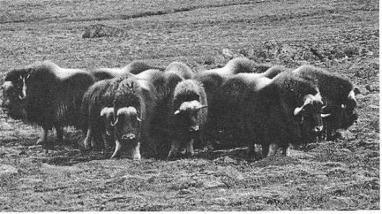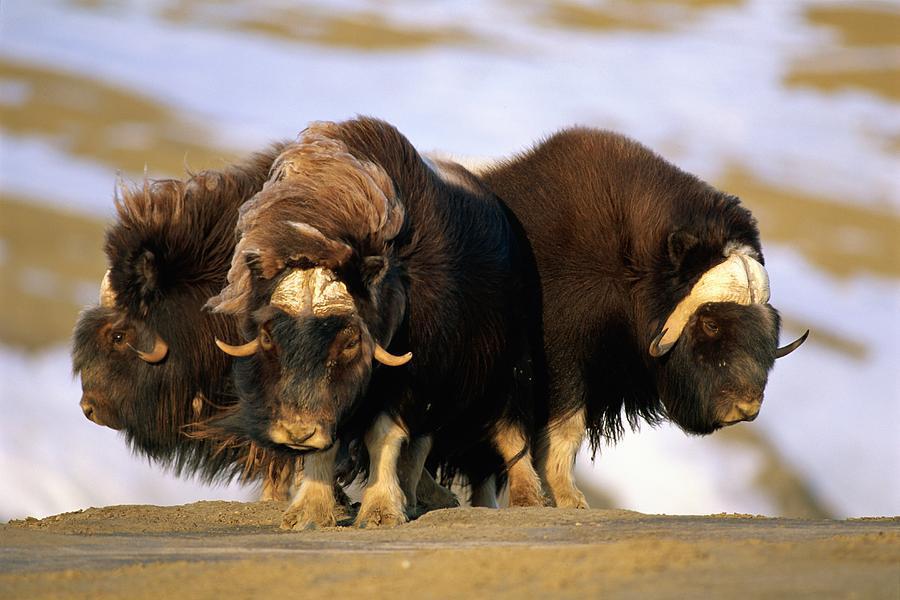The first image is the image on the left, the second image is the image on the right. For the images shown, is this caption "Buffalo are in a fanned-out circle formation, each animal looking outward, in at least one image." true? Answer yes or no. Yes. The first image is the image on the left, the second image is the image on the right. Analyze the images presented: Is the assertion "There are buffalo standing in snow." valid? Answer yes or no. No. 